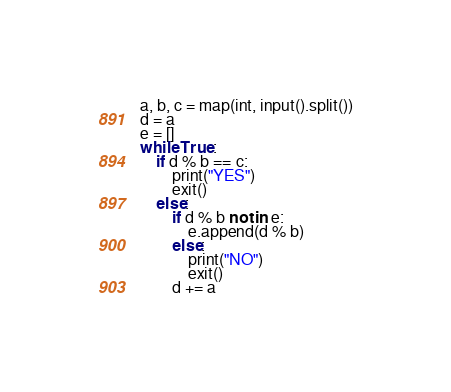<code> <loc_0><loc_0><loc_500><loc_500><_Python_>a, b, c = map(int, input().split())
d = a
e = []
while True:
    if d % b == c:
        print("YES")
        exit()
    else:
        if d % b not in e:
            e.append(d % b)
        else:
            print("NO")
            exit()
        d += a
</code> 